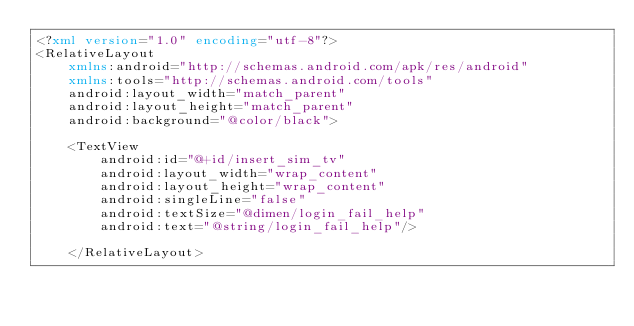<code> <loc_0><loc_0><loc_500><loc_500><_XML_><?xml version="1.0" encoding="utf-8"?>
<RelativeLayout
    xmlns:android="http://schemas.android.com/apk/res/android"
    xmlns:tools="http://schemas.android.com/tools"
    android:layout_width="match_parent"
    android:layout_height="match_parent"
    android:background="@color/black">

    <TextView
        android:id="@+id/insert_sim_tv"
        android:layout_width="wrap_content"
        android:layout_height="wrap_content"
        android:singleLine="false"
        android:textSize="@dimen/login_fail_help"
        android:text="@string/login_fail_help"/>

    </RelativeLayout>
</code> 